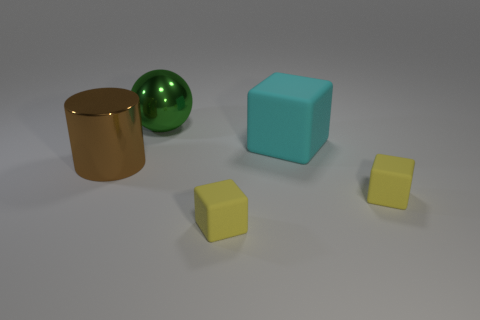Are there fewer large cyan rubber objects that are in front of the large brown thing than tiny things that are in front of the big green thing?
Provide a short and direct response. Yes. What is the material of the big brown cylinder?
Ensure brevity in your answer.  Metal. Is the color of the big metal cylinder the same as the large thing that is on the right side of the green metallic object?
Your response must be concise. No. What number of large metal cylinders are behind the large brown metal object?
Your answer should be very brief. 0. Are there fewer big shiny things that are in front of the big green metallic object than big cyan blocks?
Your answer should be very brief. No. What color is the large shiny ball?
Provide a short and direct response. Green. There is a metal object that is on the right side of the brown cylinder; does it have the same color as the big cylinder?
Make the answer very short. No. What number of big things are either blocks or yellow matte objects?
Make the answer very short. 1. What is the size of the thing that is behind the cyan thing?
Your response must be concise. Large. Is there a rubber object that has the same color as the big ball?
Make the answer very short. No. 